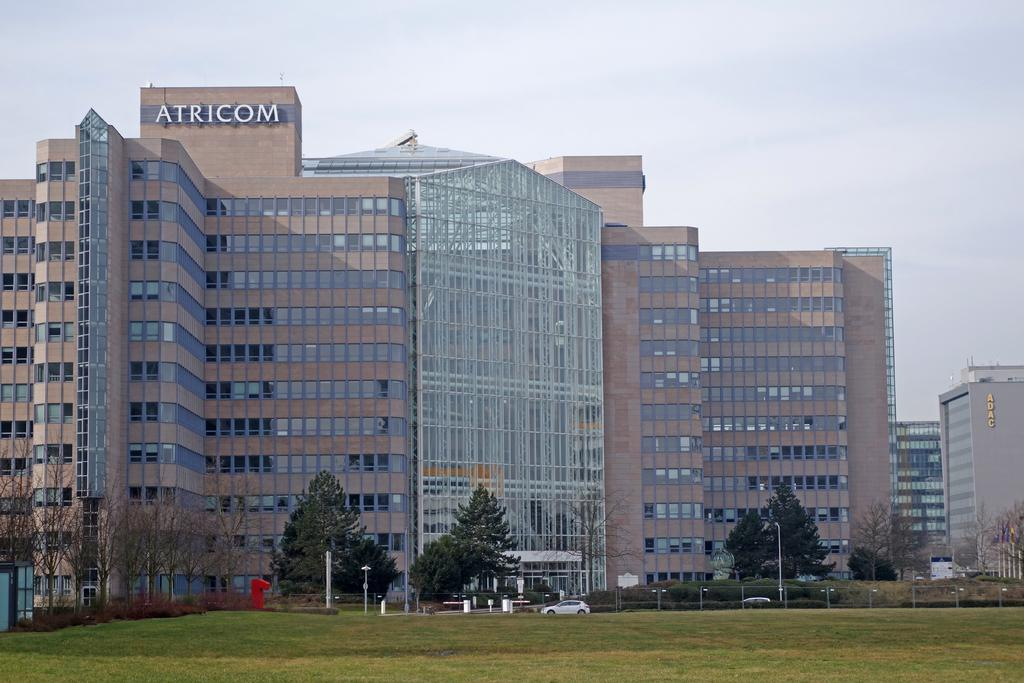What type of structures can be seen in the image? There are buildings in the image. What is located in front of the buildings? There are vehicles in front of the buildings. What type of vegetation is around the buildings? There are trees around the buildings. What type of ground cover is visible in the image? There is grass visible in the image. What type of loaf is being used to comb the trees in the image? There is no loaf or combing activity present in the image; it features buildings, vehicles, trees, and grass. 